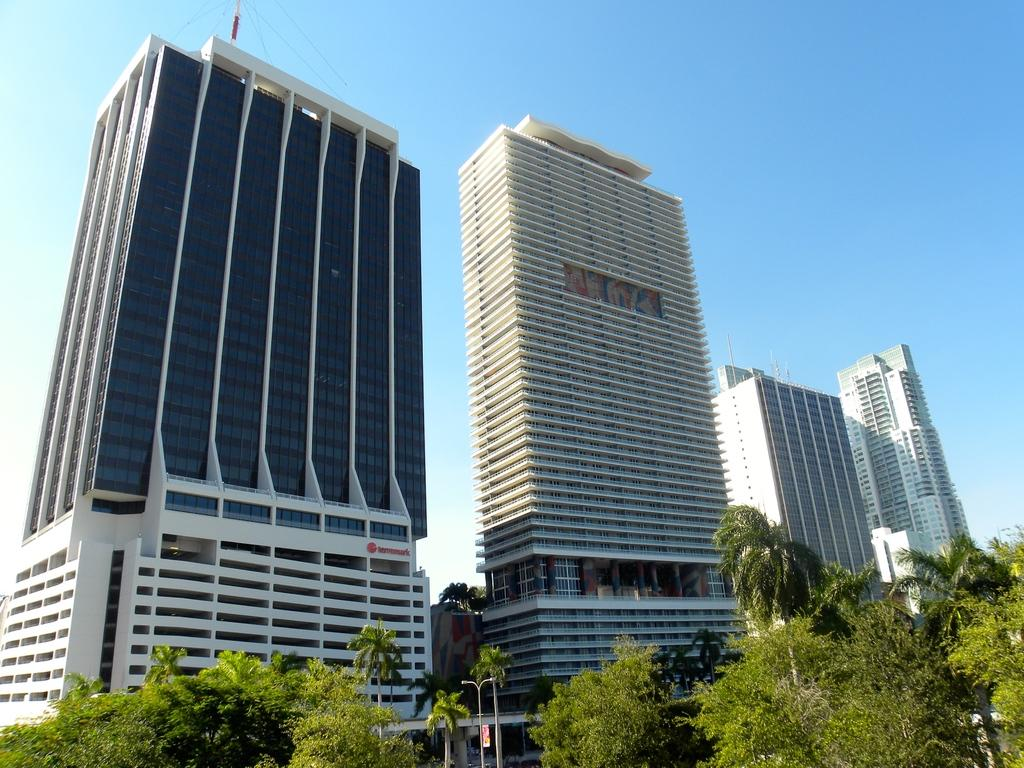What types of structures are visible in the image? There are multiple buildings in the image. What other natural elements can be seen in the image? There are trees in the image. What year is depicted in the image? The image does not depict a specific year; it only shows buildings and trees. What type of machine can be seen operating in the image? There is no machine present in the image; it only shows buildings and trees. 